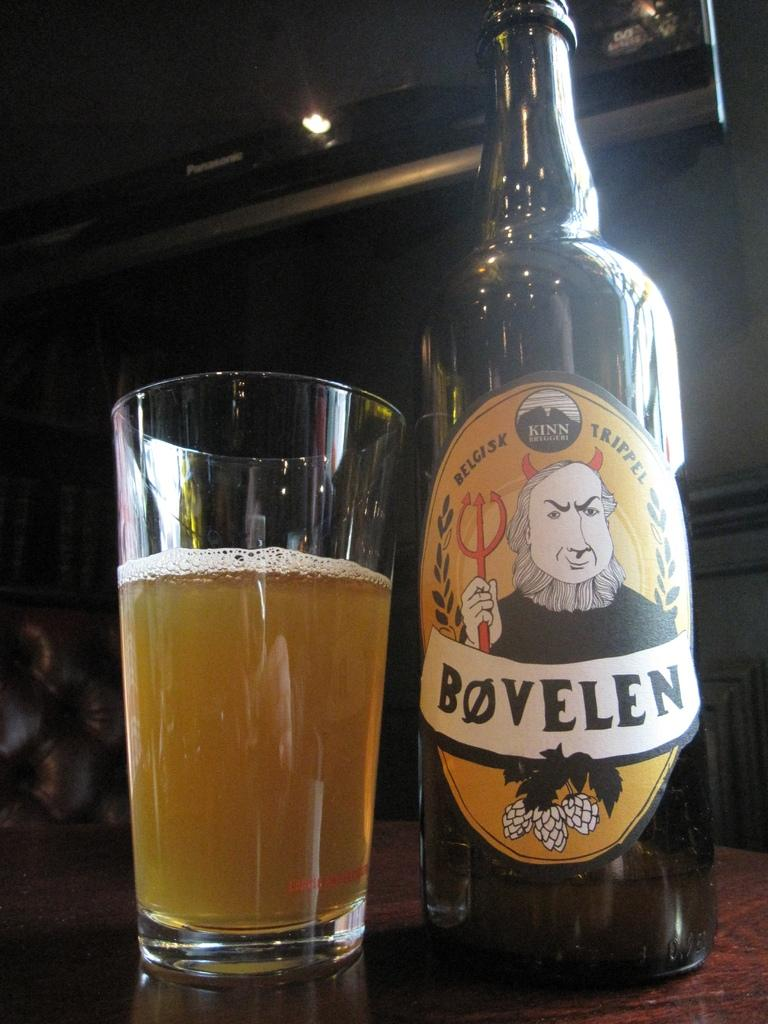<image>
Present a compact description of the photo's key features. A bottle for Bovelen ale sits next to a pint glass. 